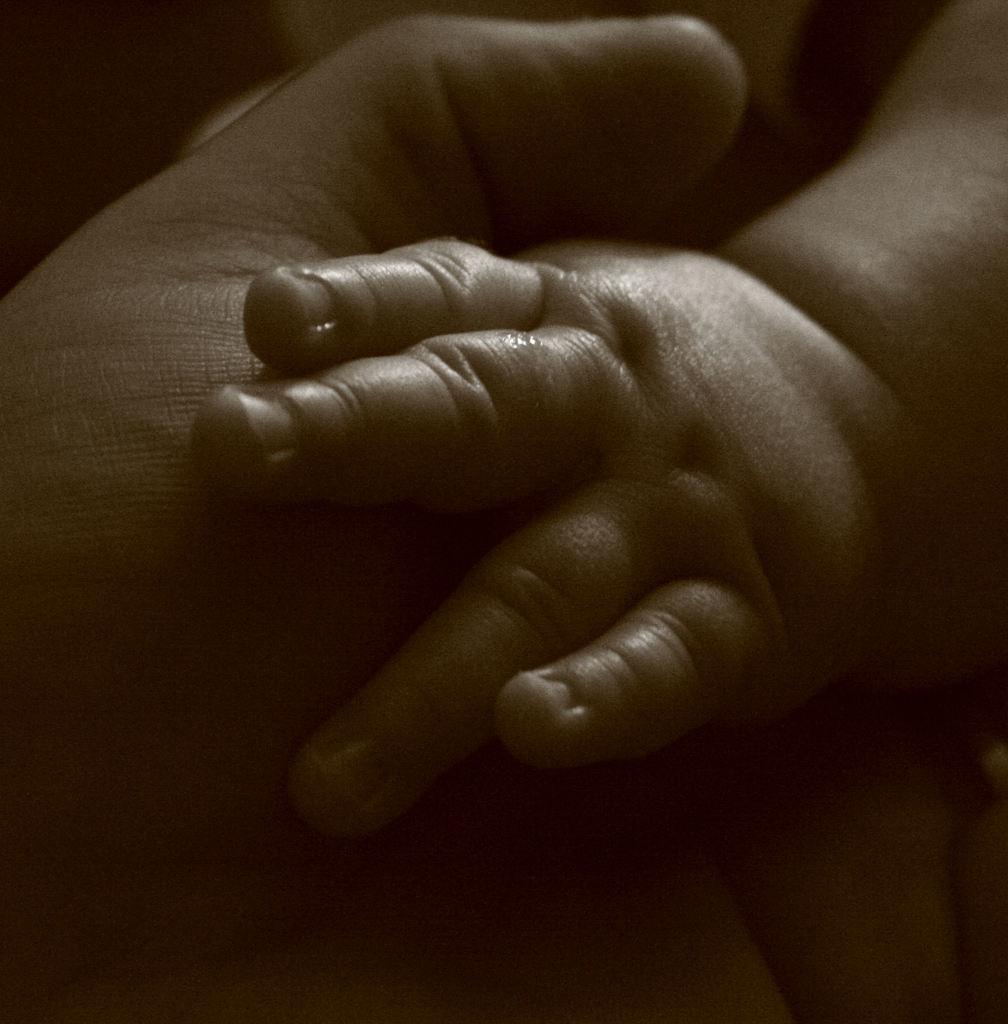Please provide a concise description of this image. In this picture there are hands in the center of the image. 